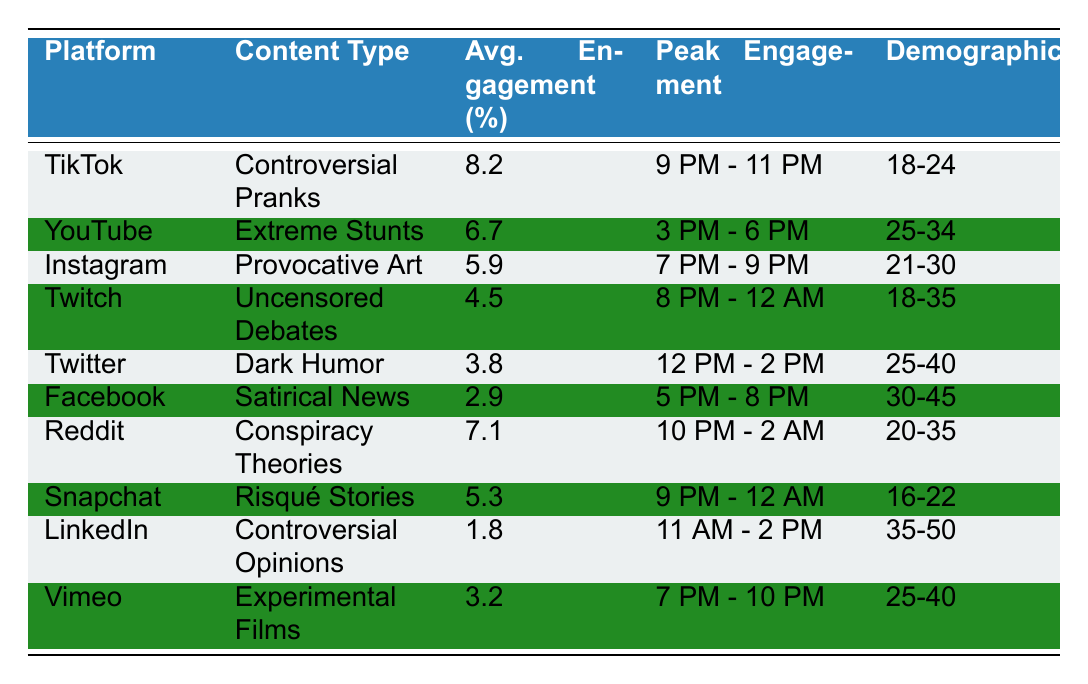What is the average engagement rate for TikTok? The engagement rate for TikTok, as listed in the table, is 8.2%.
Answer: 8.2% Which platform has the highest engagement rate? According to the table, TikTok has the highest engagement rate at 8.2%.
Answer: TikTok What is the peak engagement time for YouTube content? The table indicates that the peak engagement time for YouTube is from 3 PM to 6 PM.
Answer: 3 PM - 6 PM Which content type on Instagram has the lowest engagement rate? The table shows that "Provocative Art" on Instagram has an engagement rate of 5.9%, which is lower than the other content types listed for the platform.
Answer: Provocative Art Is dark humor more engaging on Twitter or Facebook? The engagement rate for dark humor on Twitter is 3.8%, while on Facebook it is 2.9%, indicating dark humor is more engaging on Twitter.
Answer: Twitter How does the engagement rate for Snapchat compare to Twitch? The engagement rate for Snapchat is 5.3%, which is higher than Twitch's engagement rate of 4.5%.
Answer: Higher What is the average engagement rate for Reddit and YouTube combined? The engagement rates for Reddit (7.1%) and YouTube (6.7%) add up to 13.8%, and averaging these two gives 13.8/2 = 6.9%.
Answer: 6.9% Which demographic has the highest engagement rate content type? TikTok's content type "Controversial Pranks" has the highest engagement rate (8.2%) aimed at the 18-24 demographic, which is higher than any other demographic reported in the table.
Answer: 18-24 Can we say that engagement rate decreases with age based on this data? While some platforms have lower engagement rates for older demographics, we cannot definitively conclude a trend as each platform and content type varies.
Answer: No Which content type has a peak engagement time of 10 PM to 2 AM? The table indicates that "Conspiracy Theories" on Reddit has a peak engagement time from 10 PM to 2 AM.
Answer: Conspiracy Theories If we consider the top three content types by engagement rate, what is their average engagement rate? The top three are TikTok (8.2%), Reddit (7.1%), and YouTube (6.7%). Summing these gives 22%, and dividing by 3 results in an average engagement rate of 22/3 = 7.33%.
Answer: 7.33% 